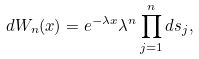Convert formula to latex. <formula><loc_0><loc_0><loc_500><loc_500>d W _ { n } ( x ) = e ^ { - \lambda x } \lambda ^ { n } \prod _ { j = 1 } ^ { n } d s _ { j } ,</formula> 